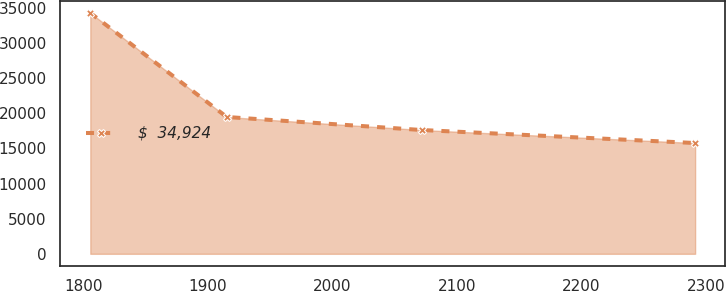Convert chart. <chart><loc_0><loc_0><loc_500><loc_500><line_chart><ecel><fcel>$  34,924<nl><fcel>1805.4<fcel>34280.4<nl><fcel>1915.03<fcel>19470<nl><fcel>2071.63<fcel>17618.7<nl><fcel>2291.2<fcel>15767.4<nl></chart> 